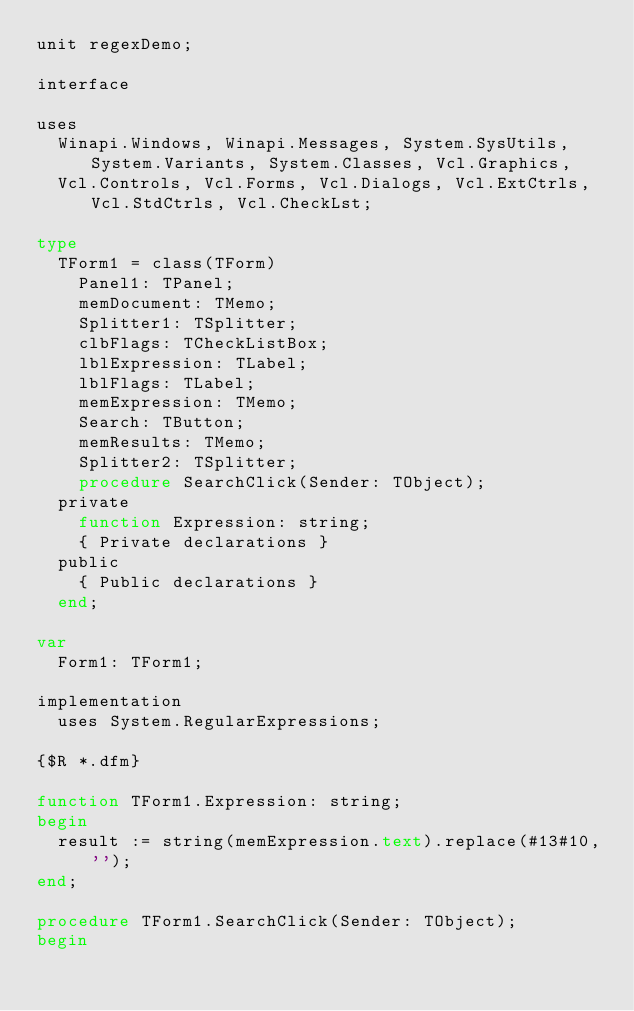Convert code to text. <code><loc_0><loc_0><loc_500><loc_500><_Pascal_>unit regexDemo;

interface

uses
  Winapi.Windows, Winapi.Messages, System.SysUtils, System.Variants, System.Classes, Vcl.Graphics,
  Vcl.Controls, Vcl.Forms, Vcl.Dialogs, Vcl.ExtCtrls, Vcl.StdCtrls, Vcl.CheckLst;

type
  TForm1 = class(TForm)
    Panel1: TPanel;
    memDocument: TMemo;
    Splitter1: TSplitter;
    clbFlags: TCheckListBox;
    lblExpression: TLabel;
    lblFlags: TLabel;
    memExpression: TMemo;
    Search: TButton;
    memResults: TMemo;
    Splitter2: TSplitter;
    procedure SearchClick(Sender: TObject);
  private
    function Expression: string;
    { Private declarations }
  public
    { Public declarations }
  end;

var
  Form1: TForm1;

implementation
  uses System.RegularExpressions;

{$R *.dfm}

function TForm1.Expression: string;
begin
  result := string(memExpression.text).replace(#13#10,'');
end;

procedure TForm1.SearchClick(Sender: TObject);
begin</code> 